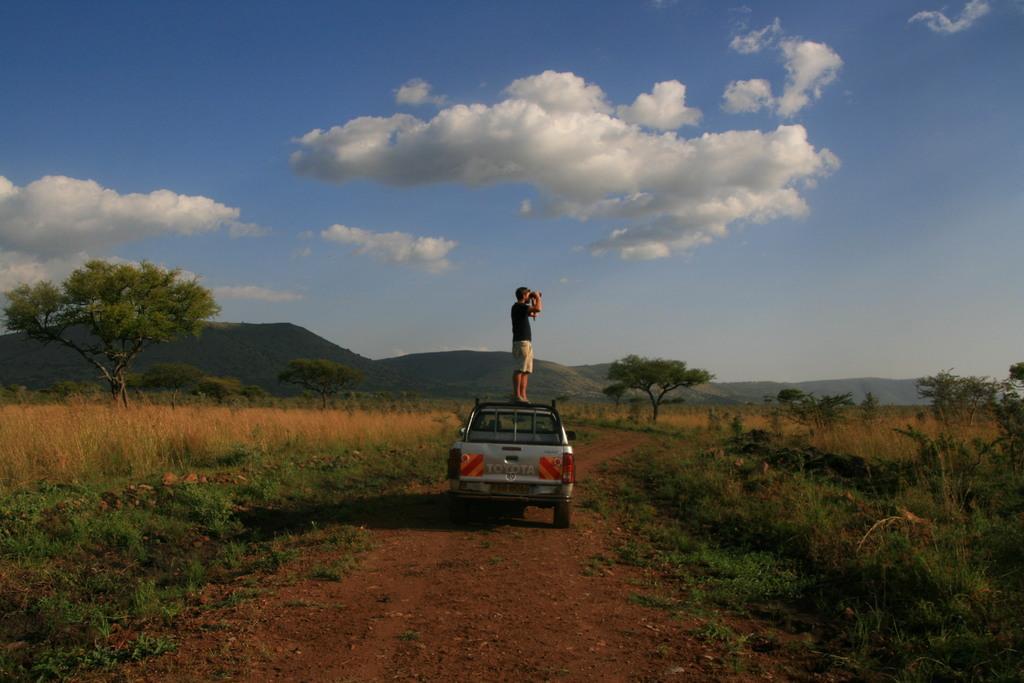How would you summarize this image in a sentence or two? In this picture we can see a man standing on top of a vehicle and the vehicle is on the ground. In front of the vehicle, there are hills and the sky. On the left and right side of the image, there are trees and grass. 